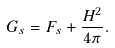Convert formula to latex. <formula><loc_0><loc_0><loc_500><loc_500>G _ { s } = F _ { s } + \frac { H ^ { 2 } } { 4 \pi } .</formula> 